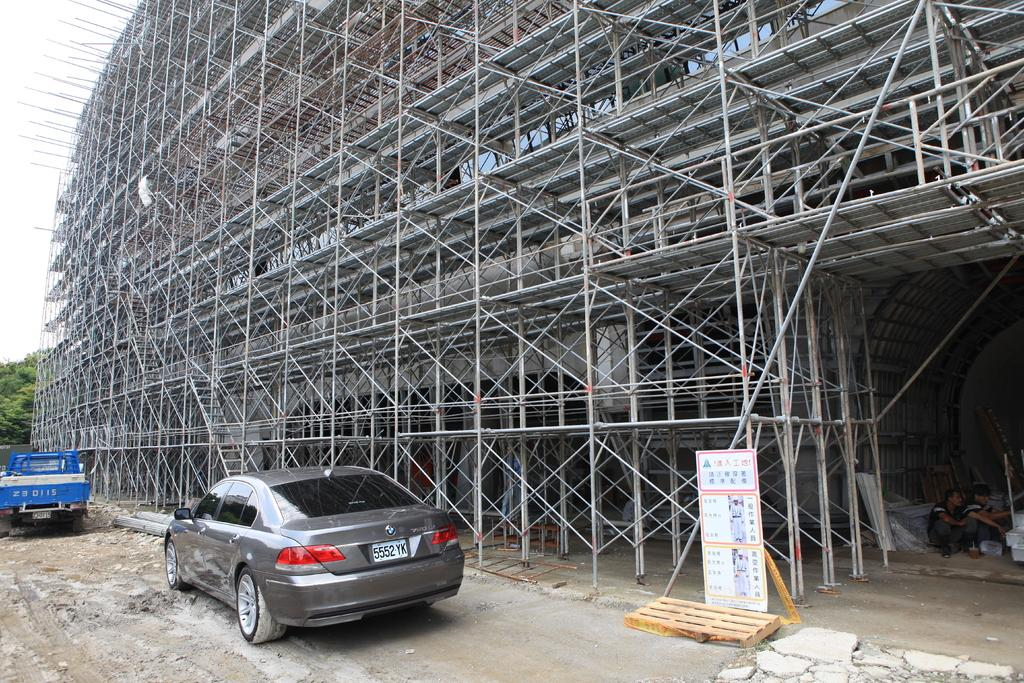What type of vehicles are on the left side of the image? There is a car and a truck on the left side of the image. What is the main subject of the image? The image shows an under-construction building. What else can be seen in the image besides the vehicles and building? There is a poster and two persons present in the image. What is visible in the background of the image? There are trees in the background of the image. Where is the doll located in the image? There is no doll present in the image. What type of window can be seen in the image? There is no window visible in the image. 